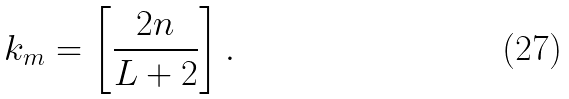Convert formula to latex. <formula><loc_0><loc_0><loc_500><loc_500>k _ { m } = \left [ \frac { 2 n } { L + 2 } \right ] .</formula> 